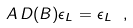<formula> <loc_0><loc_0><loc_500><loc_500>A \, D ( B ) \epsilon _ { L } = \epsilon _ { L } \ ,</formula> 